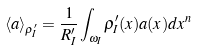<formula> <loc_0><loc_0><loc_500><loc_500>\langle a \rangle _ { \rho ^ { \prime } _ { I } } = \frac { 1 } { R ^ { \prime } _ { I } } \int _ { \omega _ { I } } \rho ^ { \prime } _ { I } ( x ) a ( x ) d x ^ { n }</formula> 